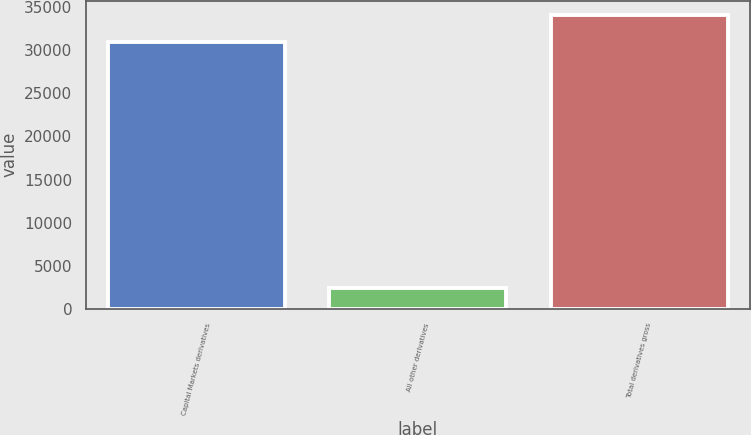Convert chart to OTSL. <chart><loc_0><loc_0><loc_500><loc_500><bar_chart><fcel>Capital Markets derivatives<fcel>All other derivatives<fcel>Total derivatives gross<nl><fcel>30930<fcel>2455<fcel>34023<nl></chart> 